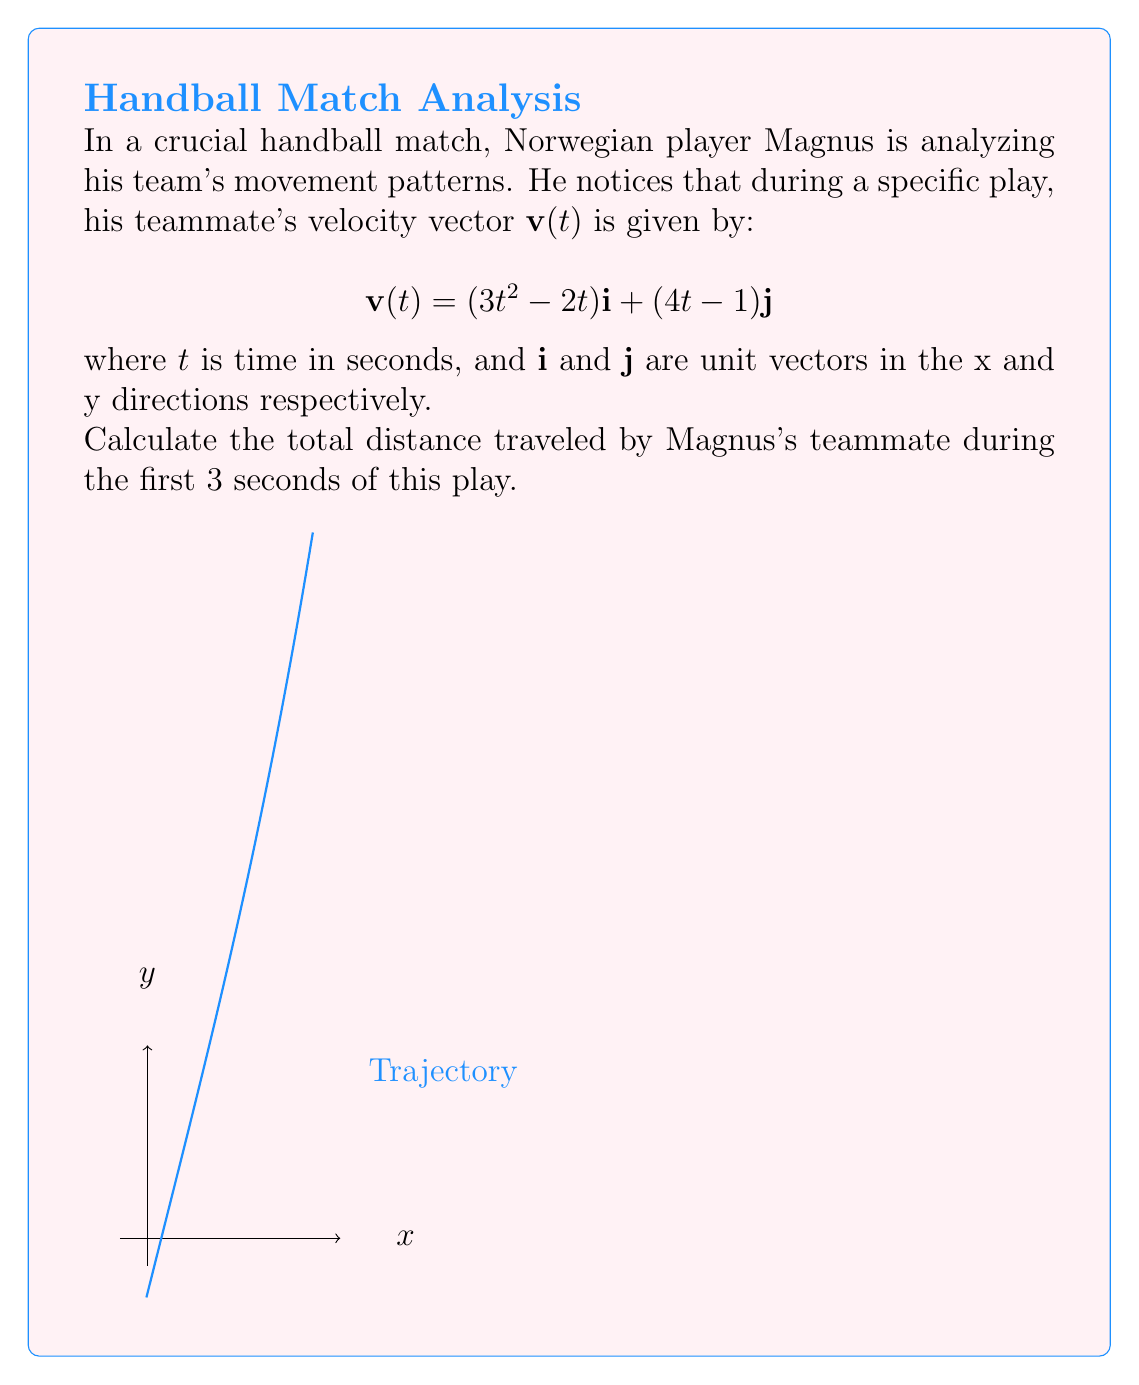Can you answer this question? To solve this problem, we'll follow these steps:

1) The position vector $\mathbf{r}(t)$ is the integral of the velocity vector $\mathbf{v}(t)$:

   $$\mathbf{r}(t) = \int \mathbf{v}(t) dt$$

2) Integrating each component:

   $$\mathbf{r}(t) = \int (3t^2 - 2t)\mathbf{i} dt + \int (4t - 1)\mathbf{j} dt$$
   $$\mathbf{r}(t) = (t^3 - t^2)\mathbf{i} + (2t^2 - t)\mathbf{j} + \mathbf{C}$$

   Where $\mathbf{C}$ is a constant vector. We can assume $\mathbf{C} = \mathbf{0}$ if the player starts at the origin.

3) To find the distance traveled, we need to calculate the arc length. The formula for arc length is:

   $$s = \int_0^3 \sqrt{\left(\frac{dx}{dt}\right)^2 + \left(\frac{dy}{dt}\right)^2} dt$$

4) We already have $\frac{dx}{dt}$ and $\frac{dy}{dt}$ from the original velocity vector:

   $$\frac{dx}{dt} = 3t^2 - 2t$$
   $$\frac{dy}{dt} = 4t - 1$$

5) Substituting into the arc length formula:

   $$s = \int_0^3 \sqrt{(3t^2 - 2t)^2 + (4t - 1)^2} dt$$

6) This integral is complex to solve analytically. We can use numerical integration methods like Simpson's rule or a computer algebra system to evaluate it.

7) Using a numerical integration method, we find:

   $$s \approx 11.62$$

Thus, the teammate travels approximately 11.62 units of distance in the first 3 seconds.
Answer: 11.62 units 